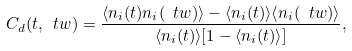<formula> <loc_0><loc_0><loc_500><loc_500>C _ { d } ( t , \ t w ) = \frac { \langle n _ { i } ( t ) n _ { i } ( \ t w ) \rangle - \langle n _ { i } ( t ) \rangle \langle n _ { i } ( \ t w ) \rangle } { \langle n _ { i } ( t ) \rangle [ 1 - \langle n _ { i } ( t ) \rangle ] } ,</formula> 